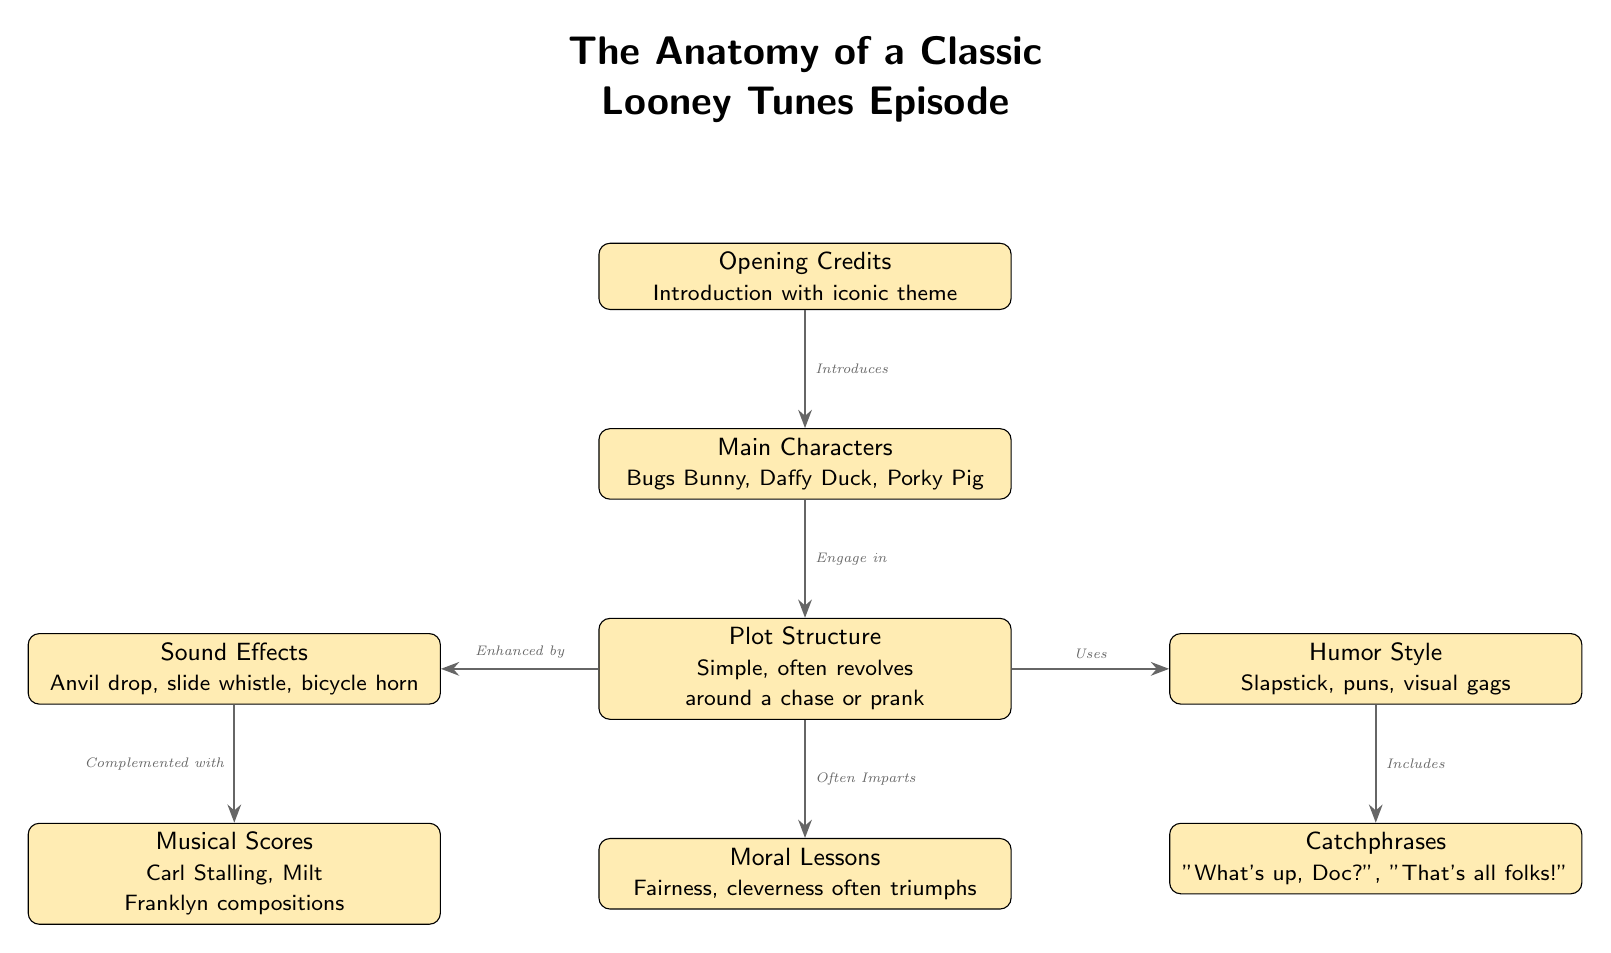What is the first component mentioned in the diagram? The first node in the diagram is labeled as "Opening Credits," which indicates it is the first component of a classic Looney Tunes episode.
Answer: Opening Credits How many main characters are listed in the diagram? The node labeled "Main Characters" specifies that the iconic characters included are Bugs Bunny, Daffy Duck, and Porky Pig, making a total of three main characters.
Answer: 3 What type of humor is used in the episodes according to the diagram? The "Humor Style" node indicates that the humor is characterized as "Slapstick, puns, visual gags," describing the overall comedic style of the episodes.
Answer: Slapstick, puns, visual gags What does the node "Moral Lessons" imply about the episode themes? The "Moral Lessons" node indicates that the episodes often impart themes of fairness and cleverness, suggesting a positive message conveyed through the episodes.
Answer: Fairness, cleverness How is the "Sound Effects" node related to the "Musical Scores" node? The "Sound Effects" node states it is "Enhanced by" and also linked to the "Musical Scores" node as being "Complemented with," indicating they both work together to enrich the audio experience of the episodes.
Answer: Enhanced by, Complemented with 